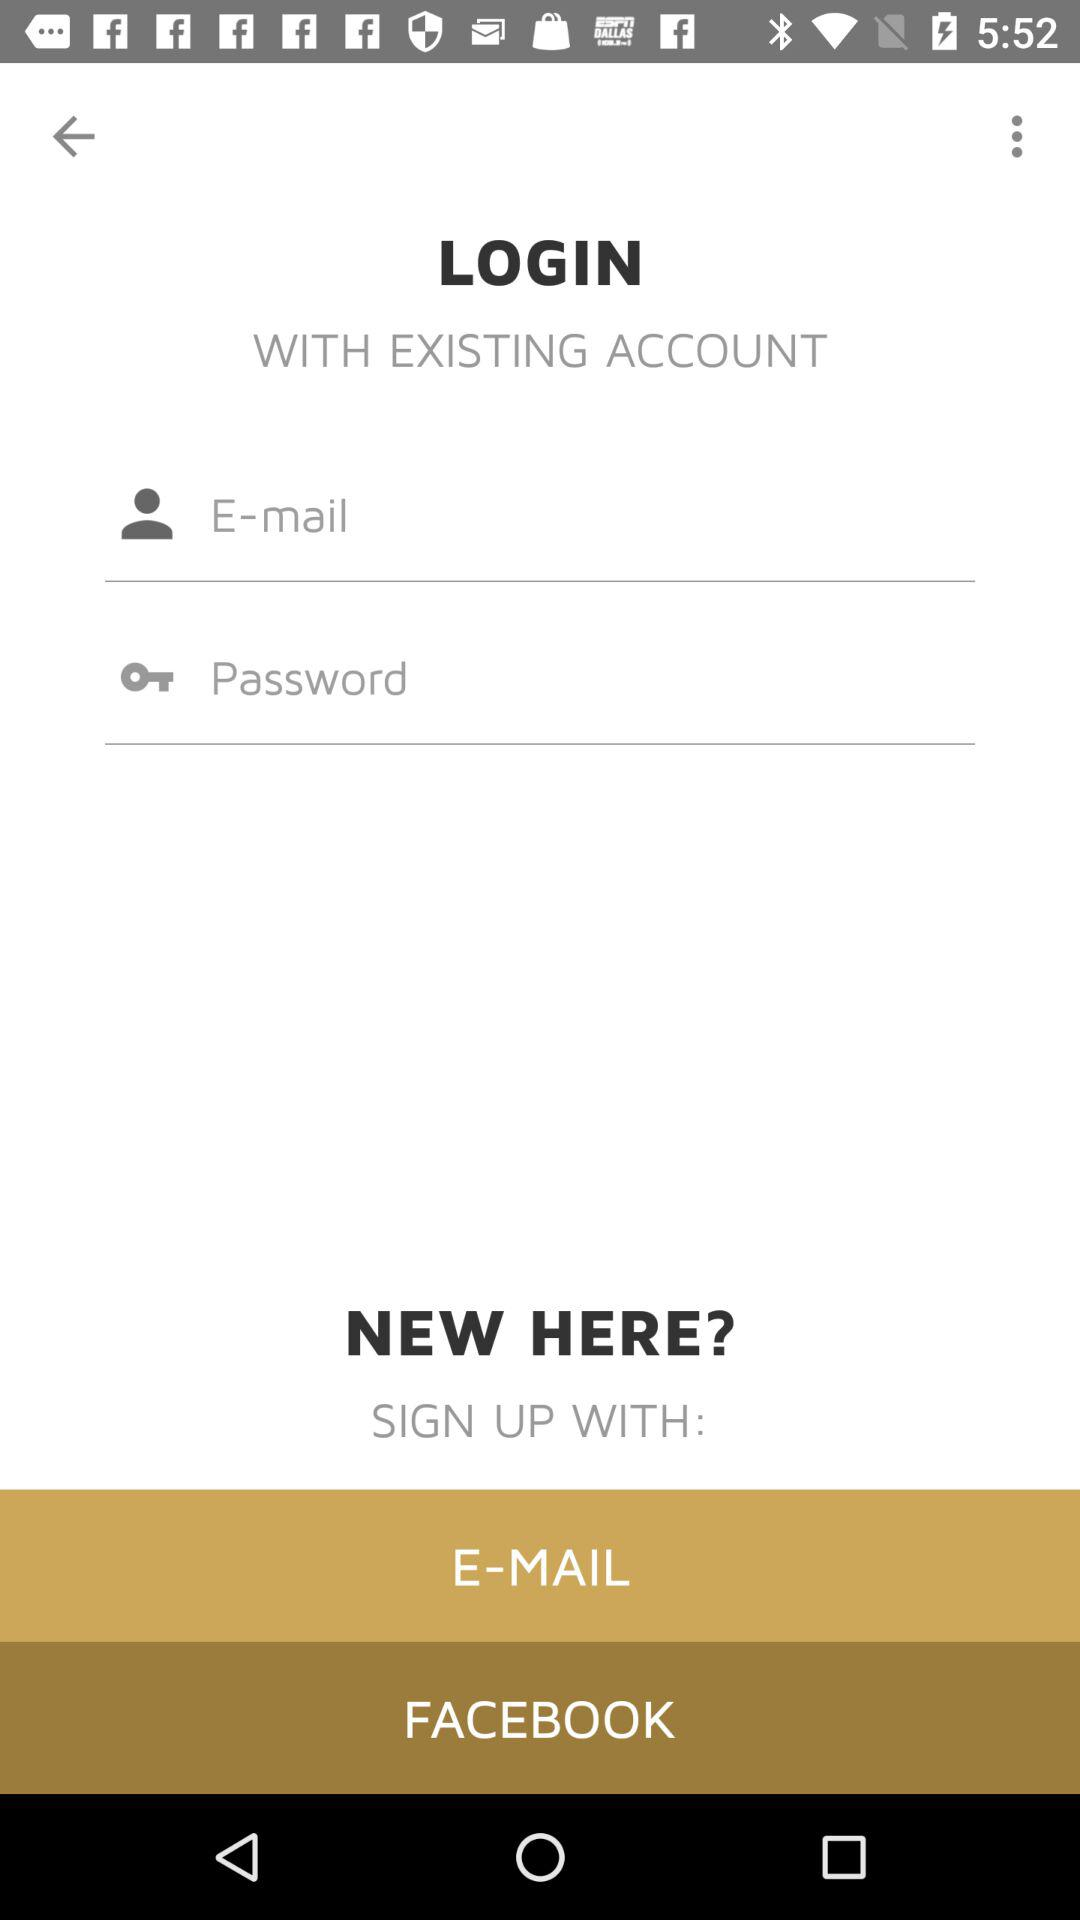How many input fields are there for signing up?
Answer the question using a single word or phrase. 2 